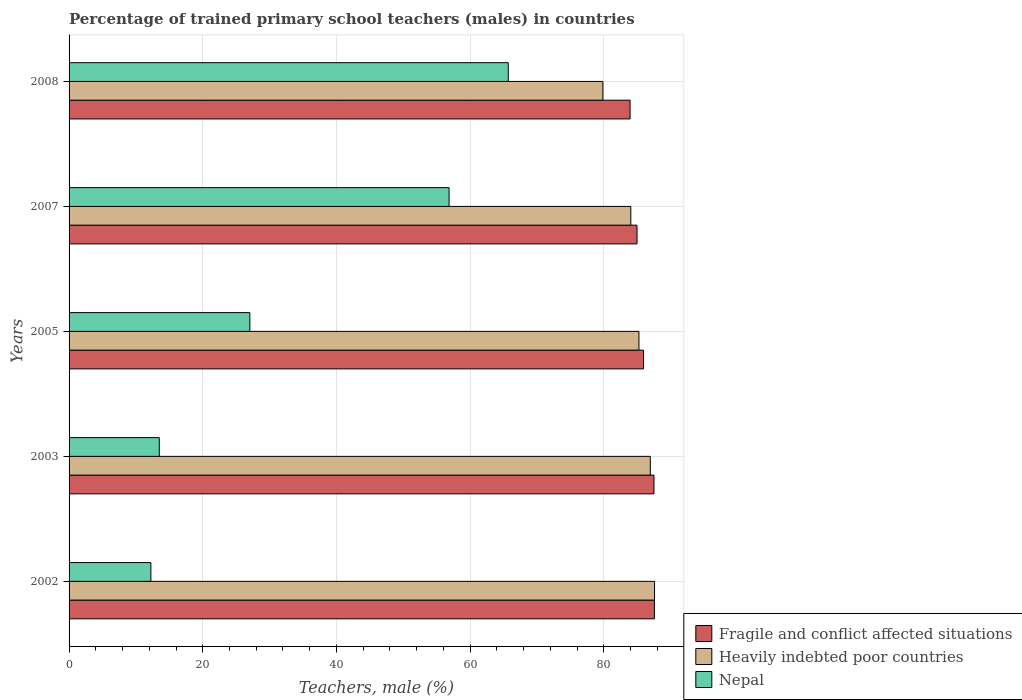How many groups of bars are there?
Keep it short and to the point. 5. Are the number of bars on each tick of the Y-axis equal?
Keep it short and to the point. Yes. How many bars are there on the 1st tick from the bottom?
Keep it short and to the point. 3. What is the percentage of trained primary school teachers (males) in Nepal in 2003?
Ensure brevity in your answer.  13.49. Across all years, what is the maximum percentage of trained primary school teachers (males) in Nepal?
Offer a very short reply. 65.7. Across all years, what is the minimum percentage of trained primary school teachers (males) in Heavily indebted poor countries?
Offer a very short reply. 79.85. In which year was the percentage of trained primary school teachers (males) in Heavily indebted poor countries maximum?
Give a very brief answer. 2002. In which year was the percentage of trained primary school teachers (males) in Fragile and conflict affected situations minimum?
Your response must be concise. 2008. What is the total percentage of trained primary school teachers (males) in Fragile and conflict affected situations in the graph?
Keep it short and to the point. 429.88. What is the difference between the percentage of trained primary school teachers (males) in Heavily indebted poor countries in 2005 and that in 2007?
Keep it short and to the point. 1.22. What is the difference between the percentage of trained primary school teachers (males) in Heavily indebted poor countries in 2003 and the percentage of trained primary school teachers (males) in Fragile and conflict affected situations in 2002?
Give a very brief answer. -0.61. What is the average percentage of trained primary school teachers (males) in Heavily indebted poor countries per year?
Make the answer very short. 84.73. In the year 2003, what is the difference between the percentage of trained primary school teachers (males) in Heavily indebted poor countries and percentage of trained primary school teachers (males) in Fragile and conflict affected situations?
Offer a terse response. -0.55. In how many years, is the percentage of trained primary school teachers (males) in Fragile and conflict affected situations greater than 52 %?
Ensure brevity in your answer.  5. What is the ratio of the percentage of trained primary school teachers (males) in Nepal in 2005 to that in 2008?
Keep it short and to the point. 0.41. Is the percentage of trained primary school teachers (males) in Nepal in 2007 less than that in 2008?
Ensure brevity in your answer.  Yes. Is the difference between the percentage of trained primary school teachers (males) in Heavily indebted poor countries in 2005 and 2007 greater than the difference between the percentage of trained primary school teachers (males) in Fragile and conflict affected situations in 2005 and 2007?
Provide a short and direct response. Yes. What is the difference between the highest and the second highest percentage of trained primary school teachers (males) in Heavily indebted poor countries?
Your response must be concise. 0.63. What is the difference between the highest and the lowest percentage of trained primary school teachers (males) in Fragile and conflict affected situations?
Provide a short and direct response. 3.64. In how many years, is the percentage of trained primary school teachers (males) in Fragile and conflict affected situations greater than the average percentage of trained primary school teachers (males) in Fragile and conflict affected situations taken over all years?
Offer a very short reply. 2. Is the sum of the percentage of trained primary school teachers (males) in Fragile and conflict affected situations in 2005 and 2007 greater than the maximum percentage of trained primary school teachers (males) in Heavily indebted poor countries across all years?
Give a very brief answer. Yes. What does the 2nd bar from the top in 2008 represents?
Ensure brevity in your answer.  Heavily indebted poor countries. What does the 3rd bar from the bottom in 2003 represents?
Your answer should be compact. Nepal. How many years are there in the graph?
Ensure brevity in your answer.  5. What is the difference between two consecutive major ticks on the X-axis?
Provide a succinct answer. 20. Does the graph contain any zero values?
Your answer should be compact. No. Where does the legend appear in the graph?
Give a very brief answer. Bottom right. How many legend labels are there?
Ensure brevity in your answer.  3. How are the legend labels stacked?
Your answer should be compact. Vertical. What is the title of the graph?
Offer a terse response. Percentage of trained primary school teachers (males) in countries. Does "Burkina Faso" appear as one of the legend labels in the graph?
Offer a very short reply. No. What is the label or title of the X-axis?
Provide a succinct answer. Teachers, male (%). What is the Teachers, male (%) in Fragile and conflict affected situations in 2002?
Give a very brief answer. 87.56. What is the Teachers, male (%) of Heavily indebted poor countries in 2002?
Provide a short and direct response. 87.58. What is the Teachers, male (%) of Nepal in 2002?
Provide a short and direct response. 12.24. What is the Teachers, male (%) of Fragile and conflict affected situations in 2003?
Your answer should be very brief. 87.5. What is the Teachers, male (%) in Heavily indebted poor countries in 2003?
Your answer should be compact. 86.95. What is the Teachers, male (%) in Nepal in 2003?
Your answer should be compact. 13.49. What is the Teachers, male (%) of Fragile and conflict affected situations in 2005?
Your response must be concise. 85.94. What is the Teachers, male (%) of Heavily indebted poor countries in 2005?
Keep it short and to the point. 85.25. What is the Teachers, male (%) of Nepal in 2005?
Offer a very short reply. 27.04. What is the Teachers, male (%) of Fragile and conflict affected situations in 2007?
Make the answer very short. 84.96. What is the Teachers, male (%) in Heavily indebted poor countries in 2007?
Provide a short and direct response. 84.03. What is the Teachers, male (%) of Nepal in 2007?
Provide a succinct answer. 56.85. What is the Teachers, male (%) in Fragile and conflict affected situations in 2008?
Keep it short and to the point. 83.92. What is the Teachers, male (%) in Heavily indebted poor countries in 2008?
Keep it short and to the point. 79.85. What is the Teachers, male (%) of Nepal in 2008?
Offer a very short reply. 65.7. Across all years, what is the maximum Teachers, male (%) in Fragile and conflict affected situations?
Offer a terse response. 87.56. Across all years, what is the maximum Teachers, male (%) of Heavily indebted poor countries?
Offer a very short reply. 87.58. Across all years, what is the maximum Teachers, male (%) of Nepal?
Your answer should be compact. 65.7. Across all years, what is the minimum Teachers, male (%) of Fragile and conflict affected situations?
Ensure brevity in your answer.  83.92. Across all years, what is the minimum Teachers, male (%) in Heavily indebted poor countries?
Your response must be concise. 79.85. Across all years, what is the minimum Teachers, male (%) in Nepal?
Your response must be concise. 12.24. What is the total Teachers, male (%) in Fragile and conflict affected situations in the graph?
Ensure brevity in your answer.  429.88. What is the total Teachers, male (%) in Heavily indebted poor countries in the graph?
Give a very brief answer. 423.65. What is the total Teachers, male (%) of Nepal in the graph?
Keep it short and to the point. 175.32. What is the difference between the Teachers, male (%) in Fragile and conflict affected situations in 2002 and that in 2003?
Provide a short and direct response. 0.07. What is the difference between the Teachers, male (%) in Heavily indebted poor countries in 2002 and that in 2003?
Your answer should be compact. 0.63. What is the difference between the Teachers, male (%) of Nepal in 2002 and that in 2003?
Your response must be concise. -1.26. What is the difference between the Teachers, male (%) in Fragile and conflict affected situations in 2002 and that in 2005?
Your answer should be compact. 1.62. What is the difference between the Teachers, male (%) of Heavily indebted poor countries in 2002 and that in 2005?
Provide a short and direct response. 2.33. What is the difference between the Teachers, male (%) of Nepal in 2002 and that in 2005?
Make the answer very short. -14.81. What is the difference between the Teachers, male (%) in Fragile and conflict affected situations in 2002 and that in 2007?
Your answer should be very brief. 2.6. What is the difference between the Teachers, male (%) in Heavily indebted poor countries in 2002 and that in 2007?
Offer a very short reply. 3.55. What is the difference between the Teachers, male (%) in Nepal in 2002 and that in 2007?
Offer a terse response. -44.61. What is the difference between the Teachers, male (%) in Fragile and conflict affected situations in 2002 and that in 2008?
Your answer should be compact. 3.64. What is the difference between the Teachers, male (%) in Heavily indebted poor countries in 2002 and that in 2008?
Offer a terse response. 7.73. What is the difference between the Teachers, male (%) of Nepal in 2002 and that in 2008?
Your response must be concise. -53.46. What is the difference between the Teachers, male (%) of Fragile and conflict affected situations in 2003 and that in 2005?
Offer a very short reply. 1.56. What is the difference between the Teachers, male (%) of Heavily indebted poor countries in 2003 and that in 2005?
Give a very brief answer. 1.7. What is the difference between the Teachers, male (%) in Nepal in 2003 and that in 2005?
Provide a short and direct response. -13.55. What is the difference between the Teachers, male (%) of Fragile and conflict affected situations in 2003 and that in 2007?
Give a very brief answer. 2.54. What is the difference between the Teachers, male (%) of Heavily indebted poor countries in 2003 and that in 2007?
Ensure brevity in your answer.  2.92. What is the difference between the Teachers, male (%) of Nepal in 2003 and that in 2007?
Offer a very short reply. -43.35. What is the difference between the Teachers, male (%) in Fragile and conflict affected situations in 2003 and that in 2008?
Your answer should be compact. 3.57. What is the difference between the Teachers, male (%) in Heavily indebted poor countries in 2003 and that in 2008?
Your response must be concise. 7.1. What is the difference between the Teachers, male (%) of Nepal in 2003 and that in 2008?
Make the answer very short. -52.21. What is the difference between the Teachers, male (%) of Fragile and conflict affected situations in 2005 and that in 2007?
Ensure brevity in your answer.  0.98. What is the difference between the Teachers, male (%) in Heavily indebted poor countries in 2005 and that in 2007?
Provide a short and direct response. 1.22. What is the difference between the Teachers, male (%) of Nepal in 2005 and that in 2007?
Keep it short and to the point. -29.8. What is the difference between the Teachers, male (%) of Fragile and conflict affected situations in 2005 and that in 2008?
Give a very brief answer. 2.02. What is the difference between the Teachers, male (%) in Heavily indebted poor countries in 2005 and that in 2008?
Offer a very short reply. 5.4. What is the difference between the Teachers, male (%) in Nepal in 2005 and that in 2008?
Your answer should be very brief. -38.66. What is the difference between the Teachers, male (%) of Fragile and conflict affected situations in 2007 and that in 2008?
Offer a terse response. 1.04. What is the difference between the Teachers, male (%) of Heavily indebted poor countries in 2007 and that in 2008?
Offer a terse response. 4.18. What is the difference between the Teachers, male (%) in Nepal in 2007 and that in 2008?
Your response must be concise. -8.85. What is the difference between the Teachers, male (%) of Fragile and conflict affected situations in 2002 and the Teachers, male (%) of Heavily indebted poor countries in 2003?
Offer a very short reply. 0.61. What is the difference between the Teachers, male (%) in Fragile and conflict affected situations in 2002 and the Teachers, male (%) in Nepal in 2003?
Provide a short and direct response. 74.07. What is the difference between the Teachers, male (%) of Heavily indebted poor countries in 2002 and the Teachers, male (%) of Nepal in 2003?
Offer a terse response. 74.08. What is the difference between the Teachers, male (%) of Fragile and conflict affected situations in 2002 and the Teachers, male (%) of Heavily indebted poor countries in 2005?
Your response must be concise. 2.31. What is the difference between the Teachers, male (%) in Fragile and conflict affected situations in 2002 and the Teachers, male (%) in Nepal in 2005?
Provide a succinct answer. 60.52. What is the difference between the Teachers, male (%) of Heavily indebted poor countries in 2002 and the Teachers, male (%) of Nepal in 2005?
Make the answer very short. 60.53. What is the difference between the Teachers, male (%) of Fragile and conflict affected situations in 2002 and the Teachers, male (%) of Heavily indebted poor countries in 2007?
Your answer should be very brief. 3.53. What is the difference between the Teachers, male (%) in Fragile and conflict affected situations in 2002 and the Teachers, male (%) in Nepal in 2007?
Ensure brevity in your answer.  30.72. What is the difference between the Teachers, male (%) in Heavily indebted poor countries in 2002 and the Teachers, male (%) in Nepal in 2007?
Offer a very short reply. 30.73. What is the difference between the Teachers, male (%) of Fragile and conflict affected situations in 2002 and the Teachers, male (%) of Heavily indebted poor countries in 2008?
Give a very brief answer. 7.71. What is the difference between the Teachers, male (%) in Fragile and conflict affected situations in 2002 and the Teachers, male (%) in Nepal in 2008?
Your answer should be compact. 21.86. What is the difference between the Teachers, male (%) of Heavily indebted poor countries in 2002 and the Teachers, male (%) of Nepal in 2008?
Your answer should be very brief. 21.88. What is the difference between the Teachers, male (%) of Fragile and conflict affected situations in 2003 and the Teachers, male (%) of Heavily indebted poor countries in 2005?
Provide a short and direct response. 2.25. What is the difference between the Teachers, male (%) of Fragile and conflict affected situations in 2003 and the Teachers, male (%) of Nepal in 2005?
Your answer should be very brief. 60.45. What is the difference between the Teachers, male (%) of Heavily indebted poor countries in 2003 and the Teachers, male (%) of Nepal in 2005?
Make the answer very short. 59.9. What is the difference between the Teachers, male (%) in Fragile and conflict affected situations in 2003 and the Teachers, male (%) in Heavily indebted poor countries in 2007?
Your answer should be very brief. 3.47. What is the difference between the Teachers, male (%) in Fragile and conflict affected situations in 2003 and the Teachers, male (%) in Nepal in 2007?
Offer a very short reply. 30.65. What is the difference between the Teachers, male (%) of Heavily indebted poor countries in 2003 and the Teachers, male (%) of Nepal in 2007?
Keep it short and to the point. 30.1. What is the difference between the Teachers, male (%) of Fragile and conflict affected situations in 2003 and the Teachers, male (%) of Heavily indebted poor countries in 2008?
Your response must be concise. 7.64. What is the difference between the Teachers, male (%) of Fragile and conflict affected situations in 2003 and the Teachers, male (%) of Nepal in 2008?
Your answer should be compact. 21.8. What is the difference between the Teachers, male (%) in Heavily indebted poor countries in 2003 and the Teachers, male (%) in Nepal in 2008?
Keep it short and to the point. 21.25. What is the difference between the Teachers, male (%) in Fragile and conflict affected situations in 2005 and the Teachers, male (%) in Heavily indebted poor countries in 2007?
Make the answer very short. 1.91. What is the difference between the Teachers, male (%) of Fragile and conflict affected situations in 2005 and the Teachers, male (%) of Nepal in 2007?
Your response must be concise. 29.09. What is the difference between the Teachers, male (%) of Heavily indebted poor countries in 2005 and the Teachers, male (%) of Nepal in 2007?
Your answer should be very brief. 28.4. What is the difference between the Teachers, male (%) in Fragile and conflict affected situations in 2005 and the Teachers, male (%) in Heavily indebted poor countries in 2008?
Provide a succinct answer. 6.09. What is the difference between the Teachers, male (%) of Fragile and conflict affected situations in 2005 and the Teachers, male (%) of Nepal in 2008?
Your response must be concise. 20.24. What is the difference between the Teachers, male (%) in Heavily indebted poor countries in 2005 and the Teachers, male (%) in Nepal in 2008?
Your answer should be very brief. 19.55. What is the difference between the Teachers, male (%) in Fragile and conflict affected situations in 2007 and the Teachers, male (%) in Heavily indebted poor countries in 2008?
Give a very brief answer. 5.11. What is the difference between the Teachers, male (%) of Fragile and conflict affected situations in 2007 and the Teachers, male (%) of Nepal in 2008?
Offer a very short reply. 19.26. What is the difference between the Teachers, male (%) of Heavily indebted poor countries in 2007 and the Teachers, male (%) of Nepal in 2008?
Ensure brevity in your answer.  18.33. What is the average Teachers, male (%) in Fragile and conflict affected situations per year?
Ensure brevity in your answer.  85.97. What is the average Teachers, male (%) in Heavily indebted poor countries per year?
Offer a very short reply. 84.73. What is the average Teachers, male (%) in Nepal per year?
Your response must be concise. 35.06. In the year 2002, what is the difference between the Teachers, male (%) of Fragile and conflict affected situations and Teachers, male (%) of Heavily indebted poor countries?
Make the answer very short. -0.02. In the year 2002, what is the difference between the Teachers, male (%) of Fragile and conflict affected situations and Teachers, male (%) of Nepal?
Your answer should be compact. 75.33. In the year 2002, what is the difference between the Teachers, male (%) of Heavily indebted poor countries and Teachers, male (%) of Nepal?
Offer a terse response. 75.34. In the year 2003, what is the difference between the Teachers, male (%) of Fragile and conflict affected situations and Teachers, male (%) of Heavily indebted poor countries?
Offer a terse response. 0.55. In the year 2003, what is the difference between the Teachers, male (%) in Fragile and conflict affected situations and Teachers, male (%) in Nepal?
Your response must be concise. 74. In the year 2003, what is the difference between the Teachers, male (%) in Heavily indebted poor countries and Teachers, male (%) in Nepal?
Offer a terse response. 73.45. In the year 2005, what is the difference between the Teachers, male (%) of Fragile and conflict affected situations and Teachers, male (%) of Heavily indebted poor countries?
Provide a succinct answer. 0.69. In the year 2005, what is the difference between the Teachers, male (%) in Fragile and conflict affected situations and Teachers, male (%) in Nepal?
Provide a short and direct response. 58.89. In the year 2005, what is the difference between the Teachers, male (%) in Heavily indebted poor countries and Teachers, male (%) in Nepal?
Make the answer very short. 58.2. In the year 2007, what is the difference between the Teachers, male (%) in Fragile and conflict affected situations and Teachers, male (%) in Heavily indebted poor countries?
Your response must be concise. 0.93. In the year 2007, what is the difference between the Teachers, male (%) in Fragile and conflict affected situations and Teachers, male (%) in Nepal?
Provide a short and direct response. 28.11. In the year 2007, what is the difference between the Teachers, male (%) of Heavily indebted poor countries and Teachers, male (%) of Nepal?
Your answer should be compact. 27.18. In the year 2008, what is the difference between the Teachers, male (%) of Fragile and conflict affected situations and Teachers, male (%) of Heavily indebted poor countries?
Make the answer very short. 4.07. In the year 2008, what is the difference between the Teachers, male (%) in Fragile and conflict affected situations and Teachers, male (%) in Nepal?
Ensure brevity in your answer.  18.22. In the year 2008, what is the difference between the Teachers, male (%) of Heavily indebted poor countries and Teachers, male (%) of Nepal?
Offer a very short reply. 14.15. What is the ratio of the Teachers, male (%) in Fragile and conflict affected situations in 2002 to that in 2003?
Offer a terse response. 1. What is the ratio of the Teachers, male (%) in Heavily indebted poor countries in 2002 to that in 2003?
Your answer should be compact. 1.01. What is the ratio of the Teachers, male (%) of Nepal in 2002 to that in 2003?
Your answer should be compact. 0.91. What is the ratio of the Teachers, male (%) of Fragile and conflict affected situations in 2002 to that in 2005?
Your response must be concise. 1.02. What is the ratio of the Teachers, male (%) in Heavily indebted poor countries in 2002 to that in 2005?
Offer a terse response. 1.03. What is the ratio of the Teachers, male (%) in Nepal in 2002 to that in 2005?
Keep it short and to the point. 0.45. What is the ratio of the Teachers, male (%) of Fragile and conflict affected situations in 2002 to that in 2007?
Give a very brief answer. 1.03. What is the ratio of the Teachers, male (%) in Heavily indebted poor countries in 2002 to that in 2007?
Give a very brief answer. 1.04. What is the ratio of the Teachers, male (%) of Nepal in 2002 to that in 2007?
Your response must be concise. 0.22. What is the ratio of the Teachers, male (%) of Fragile and conflict affected situations in 2002 to that in 2008?
Ensure brevity in your answer.  1.04. What is the ratio of the Teachers, male (%) in Heavily indebted poor countries in 2002 to that in 2008?
Provide a short and direct response. 1.1. What is the ratio of the Teachers, male (%) in Nepal in 2002 to that in 2008?
Keep it short and to the point. 0.19. What is the ratio of the Teachers, male (%) of Fragile and conflict affected situations in 2003 to that in 2005?
Ensure brevity in your answer.  1.02. What is the ratio of the Teachers, male (%) in Heavily indebted poor countries in 2003 to that in 2005?
Your answer should be compact. 1.02. What is the ratio of the Teachers, male (%) of Nepal in 2003 to that in 2005?
Give a very brief answer. 0.5. What is the ratio of the Teachers, male (%) in Fragile and conflict affected situations in 2003 to that in 2007?
Make the answer very short. 1.03. What is the ratio of the Teachers, male (%) of Heavily indebted poor countries in 2003 to that in 2007?
Provide a short and direct response. 1.03. What is the ratio of the Teachers, male (%) in Nepal in 2003 to that in 2007?
Ensure brevity in your answer.  0.24. What is the ratio of the Teachers, male (%) of Fragile and conflict affected situations in 2003 to that in 2008?
Keep it short and to the point. 1.04. What is the ratio of the Teachers, male (%) of Heavily indebted poor countries in 2003 to that in 2008?
Provide a short and direct response. 1.09. What is the ratio of the Teachers, male (%) of Nepal in 2003 to that in 2008?
Ensure brevity in your answer.  0.21. What is the ratio of the Teachers, male (%) of Fragile and conflict affected situations in 2005 to that in 2007?
Your answer should be very brief. 1.01. What is the ratio of the Teachers, male (%) in Heavily indebted poor countries in 2005 to that in 2007?
Offer a very short reply. 1.01. What is the ratio of the Teachers, male (%) in Nepal in 2005 to that in 2007?
Your answer should be compact. 0.48. What is the ratio of the Teachers, male (%) of Fragile and conflict affected situations in 2005 to that in 2008?
Provide a succinct answer. 1.02. What is the ratio of the Teachers, male (%) in Heavily indebted poor countries in 2005 to that in 2008?
Offer a terse response. 1.07. What is the ratio of the Teachers, male (%) of Nepal in 2005 to that in 2008?
Provide a succinct answer. 0.41. What is the ratio of the Teachers, male (%) in Fragile and conflict affected situations in 2007 to that in 2008?
Provide a succinct answer. 1.01. What is the ratio of the Teachers, male (%) in Heavily indebted poor countries in 2007 to that in 2008?
Ensure brevity in your answer.  1.05. What is the ratio of the Teachers, male (%) in Nepal in 2007 to that in 2008?
Offer a very short reply. 0.87. What is the difference between the highest and the second highest Teachers, male (%) of Fragile and conflict affected situations?
Provide a succinct answer. 0.07. What is the difference between the highest and the second highest Teachers, male (%) in Heavily indebted poor countries?
Keep it short and to the point. 0.63. What is the difference between the highest and the second highest Teachers, male (%) of Nepal?
Ensure brevity in your answer.  8.85. What is the difference between the highest and the lowest Teachers, male (%) of Fragile and conflict affected situations?
Offer a very short reply. 3.64. What is the difference between the highest and the lowest Teachers, male (%) of Heavily indebted poor countries?
Provide a succinct answer. 7.73. What is the difference between the highest and the lowest Teachers, male (%) of Nepal?
Give a very brief answer. 53.46. 